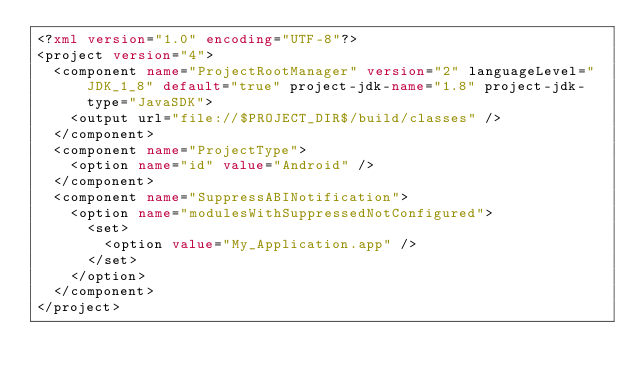<code> <loc_0><loc_0><loc_500><loc_500><_XML_><?xml version="1.0" encoding="UTF-8"?>
<project version="4">
  <component name="ProjectRootManager" version="2" languageLevel="JDK_1_8" default="true" project-jdk-name="1.8" project-jdk-type="JavaSDK">
    <output url="file://$PROJECT_DIR$/build/classes" />
  </component>
  <component name="ProjectType">
    <option name="id" value="Android" />
  </component>
  <component name="SuppressABINotification">
    <option name="modulesWithSuppressedNotConfigured">
      <set>
        <option value="My_Application.app" />
      </set>
    </option>
  </component>
</project></code> 